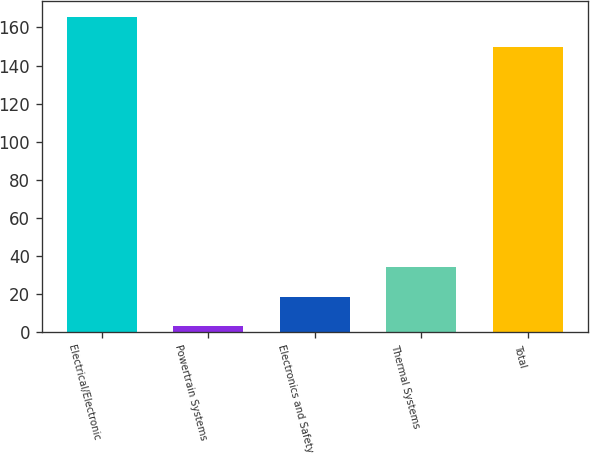<chart> <loc_0><loc_0><loc_500><loc_500><bar_chart><fcel>Electrical/Electronic<fcel>Powertrain Systems<fcel>Electronics and Safety<fcel>Thermal Systems<fcel>Total<nl><fcel>165.5<fcel>3<fcel>18.5<fcel>34<fcel>150<nl></chart> 